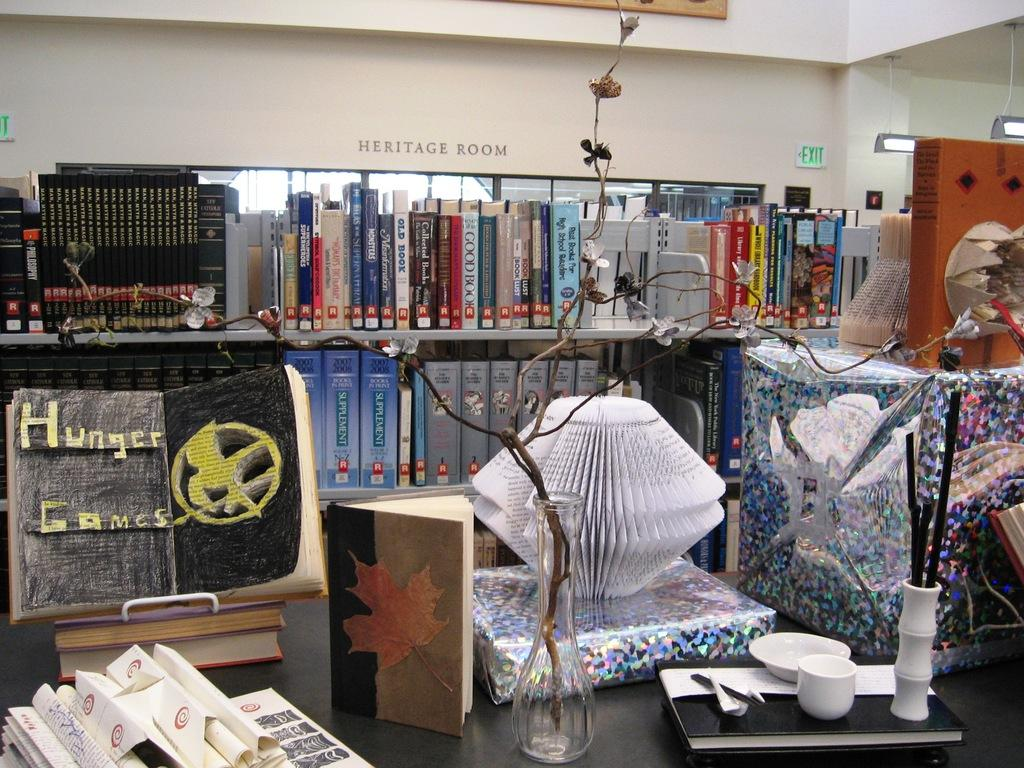<image>
Offer a succinct explanation of the picture presented. the word games is on a homemade item with a black background 